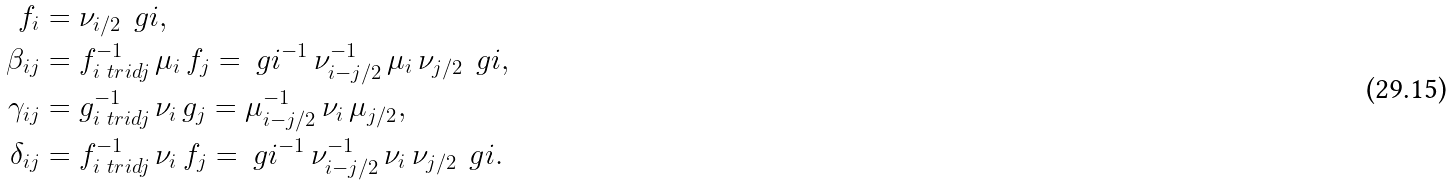Convert formula to latex. <formula><loc_0><loc_0><loc_500><loc_500>f _ { i } & = \nu _ { i / 2 } \, \ g i , \\ \beta _ { i j } & = f _ { i \ t r i d j } ^ { - 1 } \, \mu _ { i } \, f _ { j } = \ g i ^ { - 1 } \, \nu _ { i - j / 2 } ^ { - 1 } \, \mu _ { i } \, \nu _ { j / 2 } \, \ g i , \\ \gamma _ { i j } & = g _ { i \ t r i d j } ^ { - 1 } \, \nu _ { i } \, g _ { j } = \mu _ { i - j / 2 } ^ { - 1 } \, \nu _ { i } \, \mu _ { j / 2 } , \\ \delta _ { i j } & = f _ { i \ t r i d j } ^ { - 1 } \, \nu _ { i } \, f _ { j } = \ g i ^ { - 1 } \, \nu _ { i - j / 2 } ^ { - 1 } \, \nu _ { i } \, \nu _ { j / 2 } \, \ g i .</formula> 